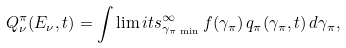Convert formula to latex. <formula><loc_0><loc_0><loc_500><loc_500>Q _ { \nu } ^ { \pi } ( E _ { \nu } , t ) = \int \lim i t s _ { \gamma _ { \pi \, \min } } ^ { \infty } \, f ( \gamma _ { \pi } ) \, q _ { \pi } ( \gamma _ { \pi } , t ) \, d \gamma _ { \pi } ,</formula> 